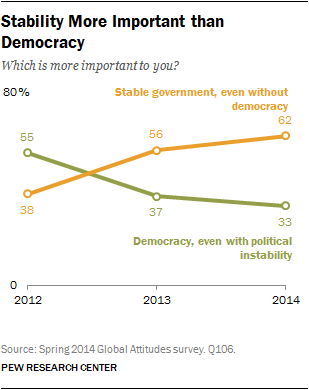Draw attention to some important aspects in this diagram. According to the graph, the value of the green line was lowest in 2014. There has been a significant change in the public's preference for stable government from 2012 to 2014, with a majority of respondents indicating a preference for stable government in 2014. 